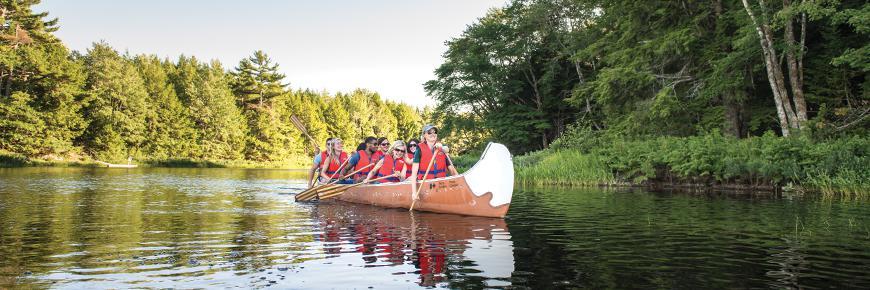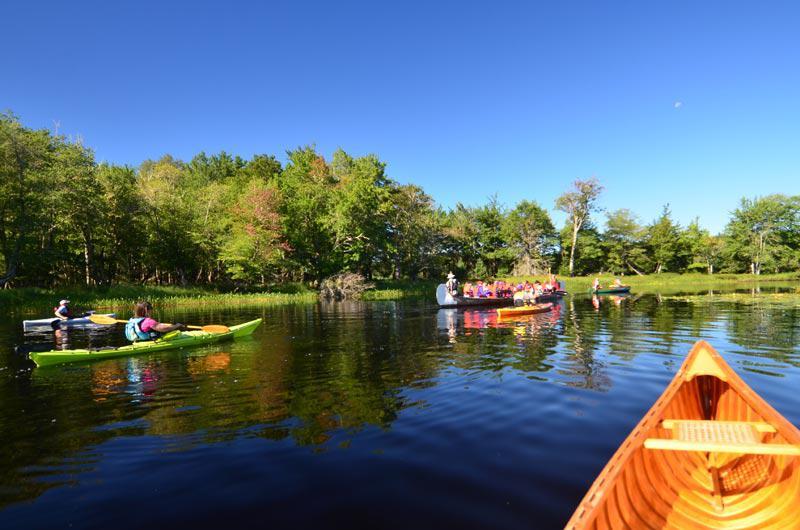The first image is the image on the left, the second image is the image on the right. Given the left and right images, does the statement "There is more than one boat in the image on the right." hold true? Answer yes or no. Yes. 